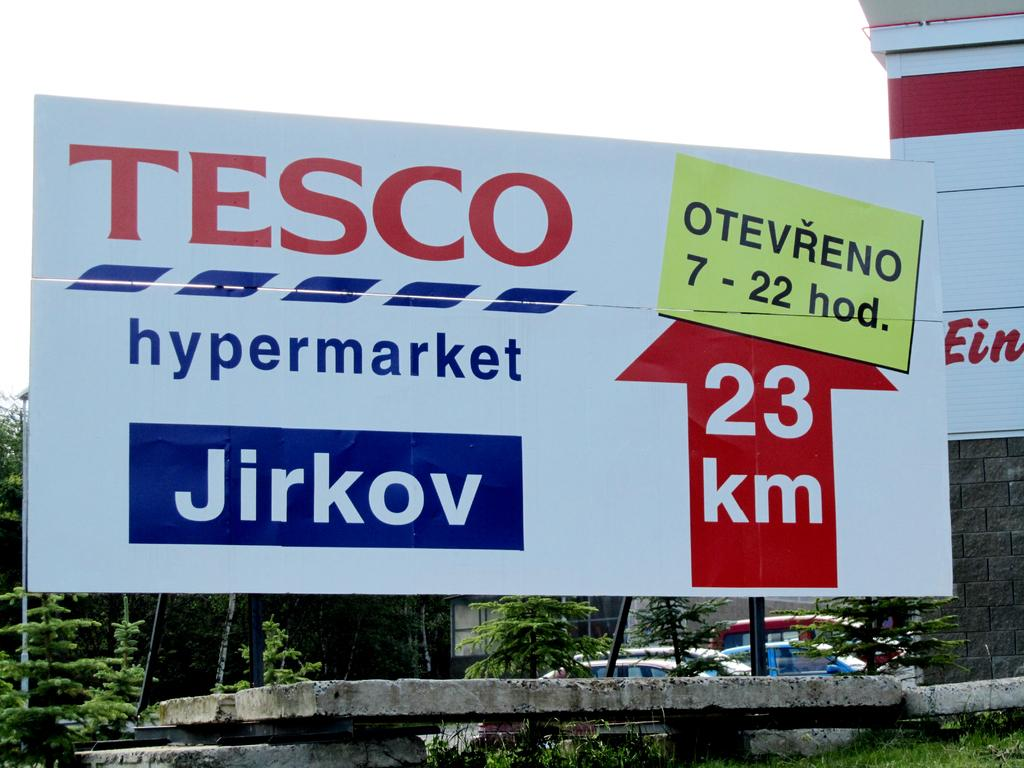<image>
Describe the image concisely. A billboard advertises Tesco Hypermarket 23 km ahead. 